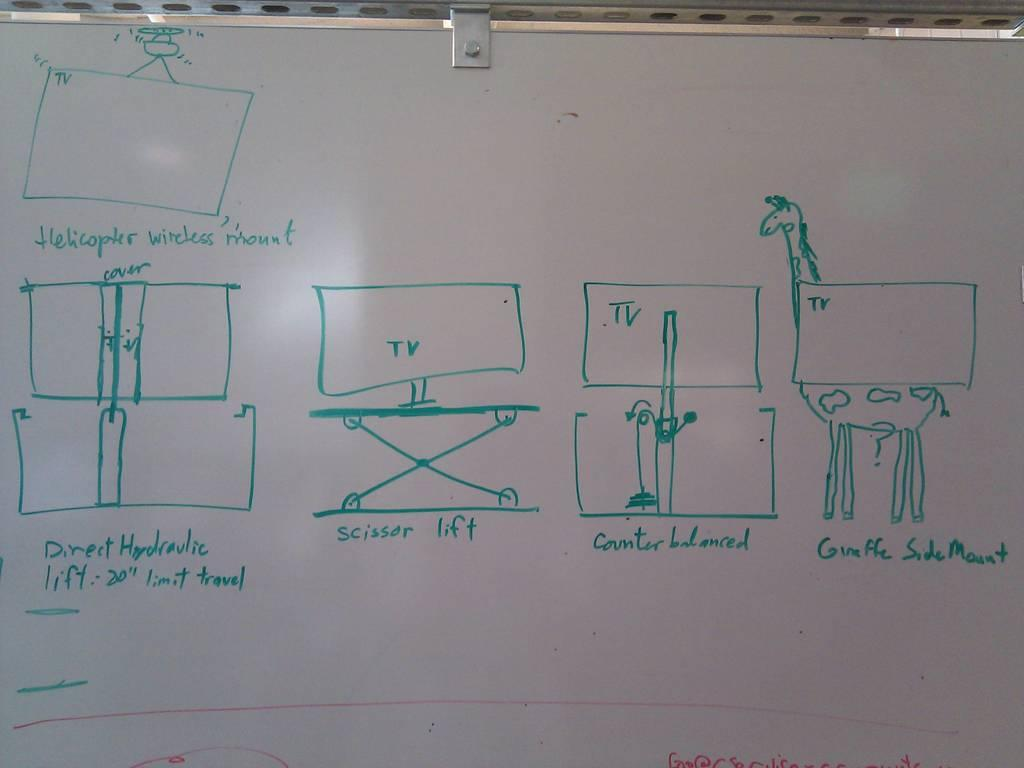<image>
Provide a brief description of the given image. A white board has the word scissor written on it 